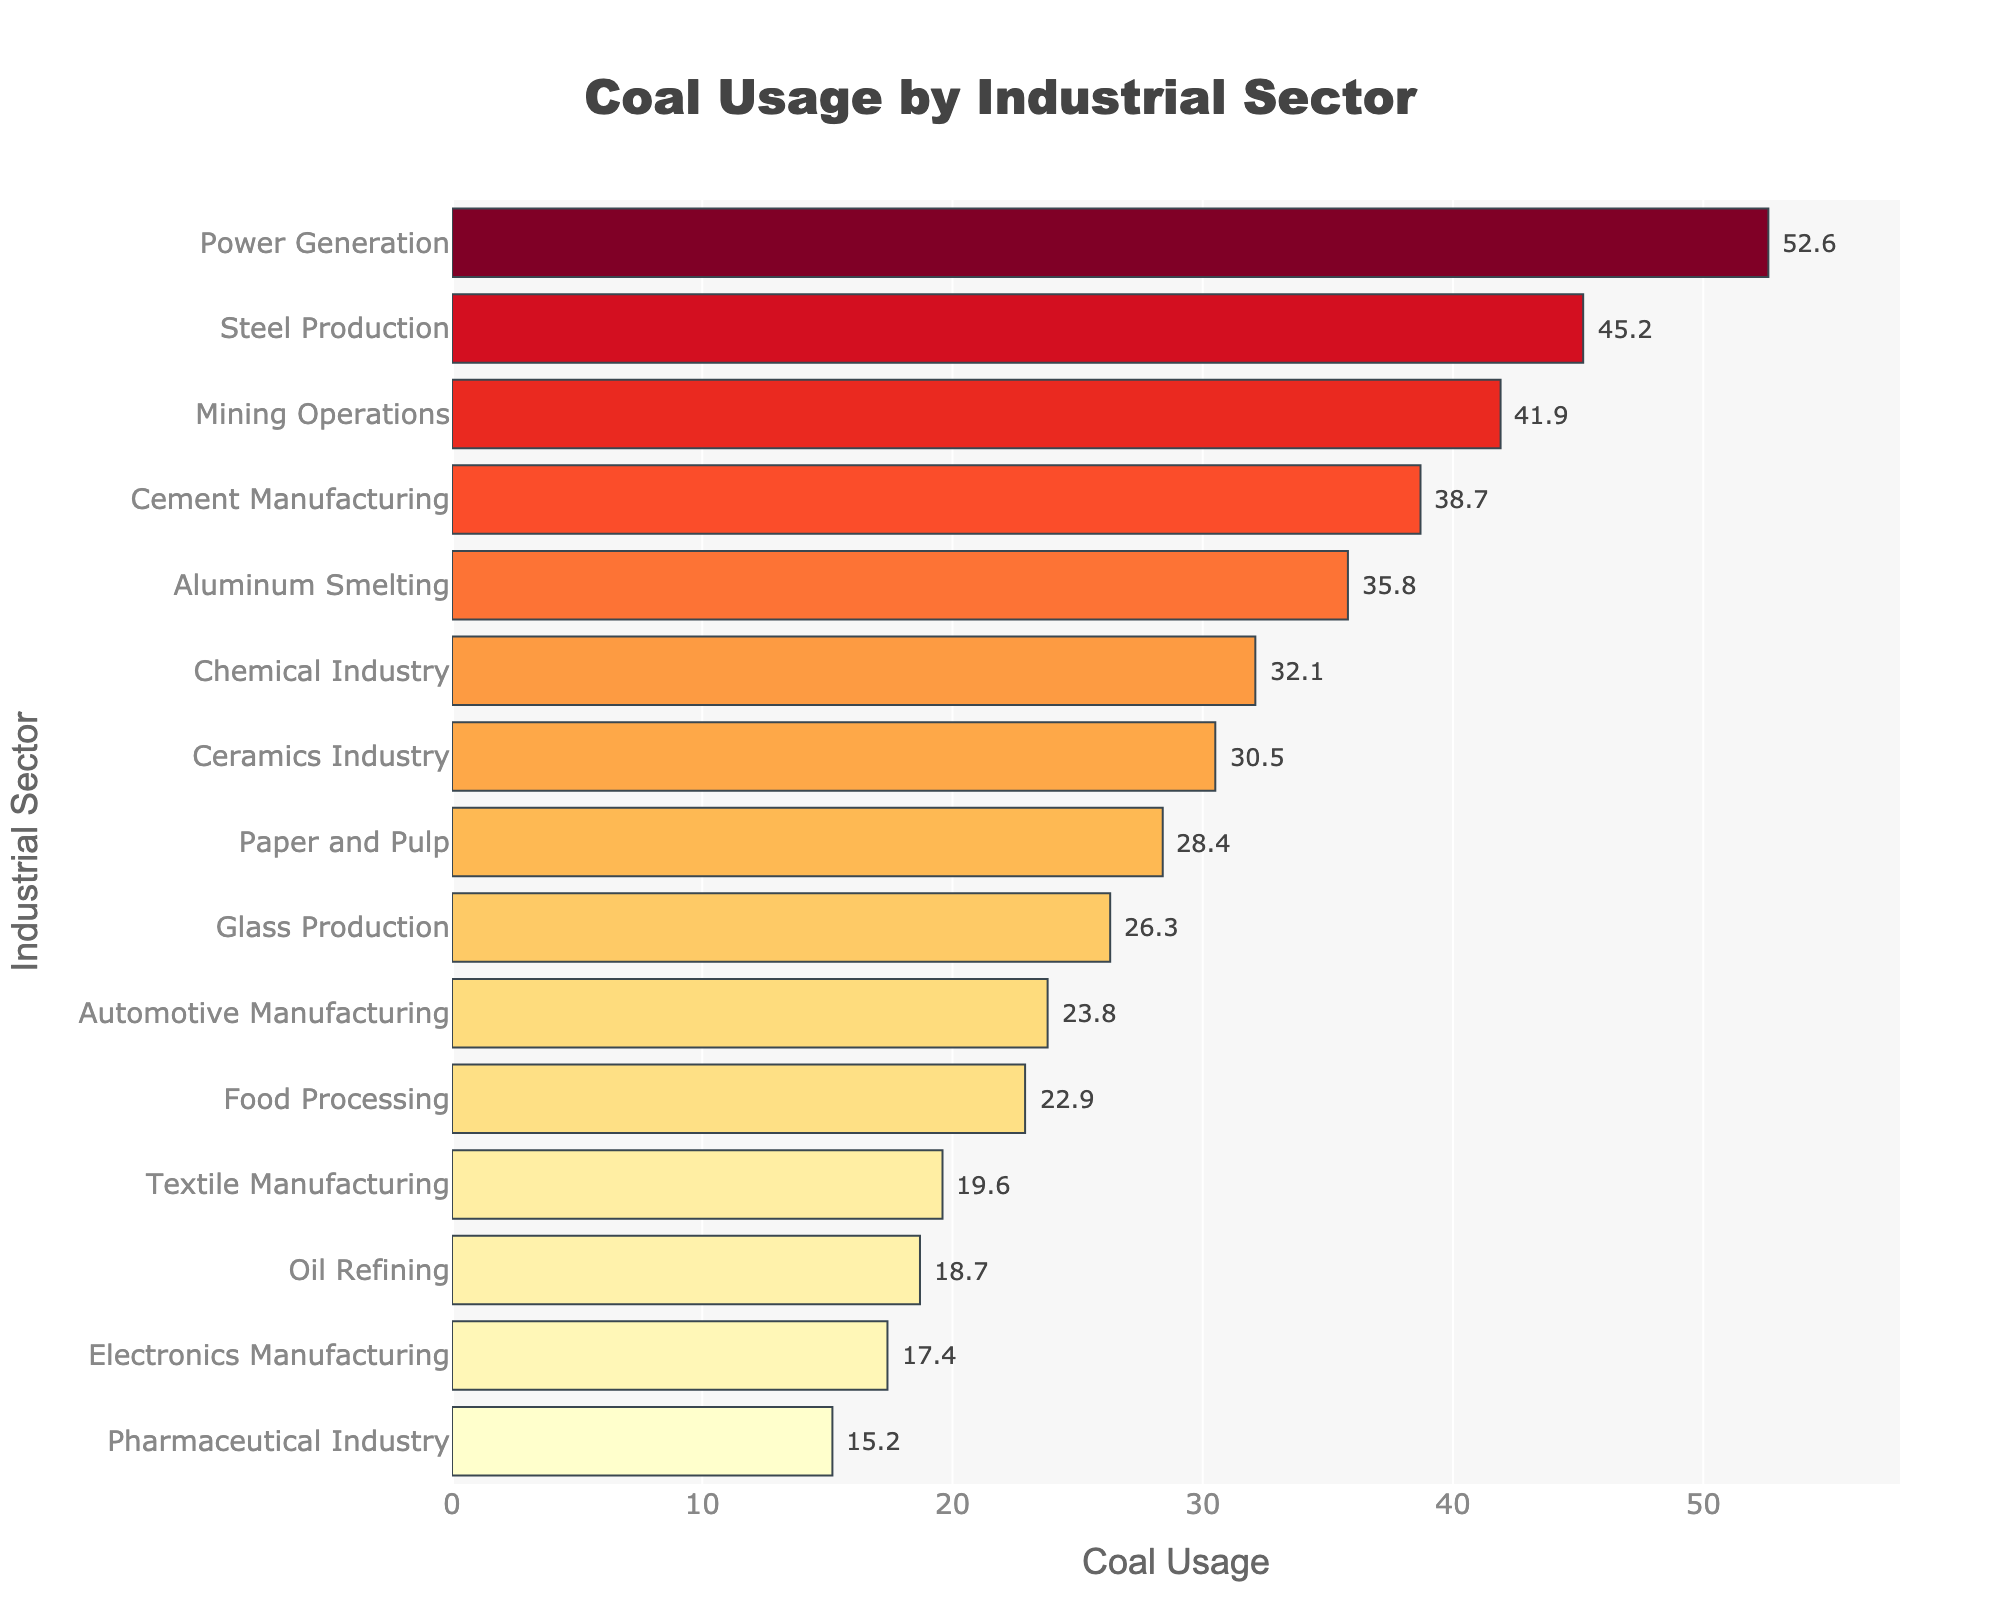what is the title of the figure? The title is usually placed at the top center of the figure and is often the most prominent text. It summarizes the main topic of the figure.
Answer: Coal Usage by Industrial Sector Which industrial sector has the highest coal usage? The bar representing the highest coal usage will be the longest one in the plot. By looking at the lengths, we can see that "Power Generation" has the longest bar.
Answer: Power Generation How much coal is used by the Mining Operations sector? Locate the bar corresponding to Mining Operations on the Y-axis. Then, track its length on the X-axis, where the value is annotated next to the bar.
Answer: 41.9 What's the difference in coal usage between Steel Production and Aluminum Smelting? Locate both sectors on the Y-axis and note their coal usage from the X-axis (annotated values). Calculate the difference: 45.2 (Steel Production) - 35.8 (Aluminum Smelting) = 9.4.
Answer: 9.4 Which sector has more coal usage: Textile Manufacturing or Food Processing? Compare the bars and the annotated values for the two sectors. Textile Manufacturing uses 19.6, while Food Processing uses 22.9.
Answer: Food Processing What’s the sum of coal usage for Chemical Industry and Paper and Pulp? Find the coal usage values for both sectors: Chemical Industry (32.1) and Paper and Pulp (28.4). Add them together: 32.1 + 28.4 = 60.5.
Answer: 60.5 How many sectors have coal usage greater than 30? Count the number of bars where the annotated value is greater than 30. The sectors are: Steel Production, Cement Manufacturing, Chemical Industry, Aluminum Smelting, Mining Operations, Power Generation, Ceramics Industry. There are 7 such sectors.
Answer: 7 Which sector has the least coal usage? Identify the bar with the shortest length on the plot and refer to the Y-axis label. The shortest bar represents the Pharmaceutical Industry.
Answer: Pharmaceutical Industry What's the average coal usage across all sectors? Sum the coal usage of all sectors and divide by the number of sectors. Total sum: 45.2 + 38.7 + 32.1 + 28.4 + 22.9 + 19.6 + 35.8 + 26.3 + 30.5 + 41.9 + 52.6 + 18.7 + 15.2 + 23.8 + 17.4 = 449.1; number of sectors: 15. Average = 449.1 / 15 = 29.94.
Answer: 29.94 